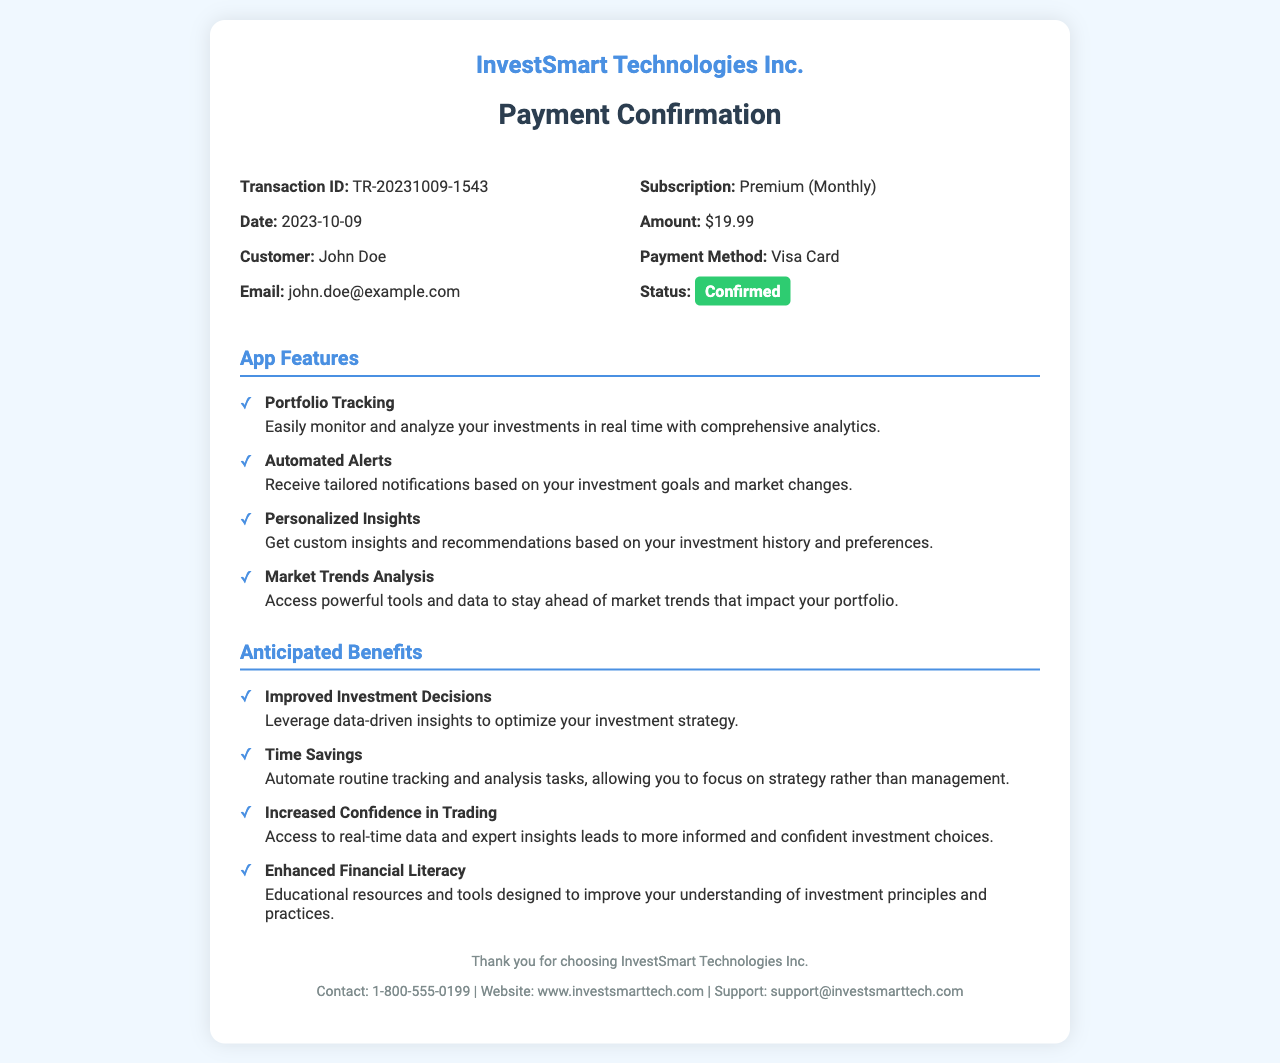What is the transaction ID? The transaction ID is a unique identifier for the payment, which can be found in the receipt details section.
Answer: TR-20231009-1543 What is the subscription type? The subscription type indicates the level of service or plan chosen, as noted in the receipt details.
Answer: Premium (Monthly) What is the payment amount? The payment amount is the total charged for the subscription, specified in the receipt details.
Answer: $19.99 What payment method was used? The payment method shows how the transaction was processed, which is mentioned in the receipt details.
Answer: Visa Card What are the anticipated benefits related to the service? The anticipated benefits list provides insights on how the service can positively affect the user’s investment management.
Answer: Improved Investment Decisions How many features are listed in the document? The count of features highlights the scope of the app's offerings detailed in the features section.
Answer: 4 What is the payment status? The payment status indicates whether the payment was successful or failed, as shown in the receipt details.
Answer: Confirmed What is the company name? The company name identifies the organization providing the service, which is stated at the top of the receipt.
Answer: InvestSmart Technologies Inc What should a user do if they need support? The support information provides a direct means of contact for customer assistance referenced at the bottom of the document.
Answer: support@investsmarttech.com 